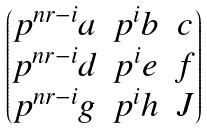<formula> <loc_0><loc_0><loc_500><loc_500>\begin{pmatrix} p ^ { n r - i } a & p ^ { i } b & c \\ p ^ { n r - i } d & p ^ { i } e & f \\ p ^ { n r - i } g & p ^ { i } h & J \end{pmatrix}</formula> 